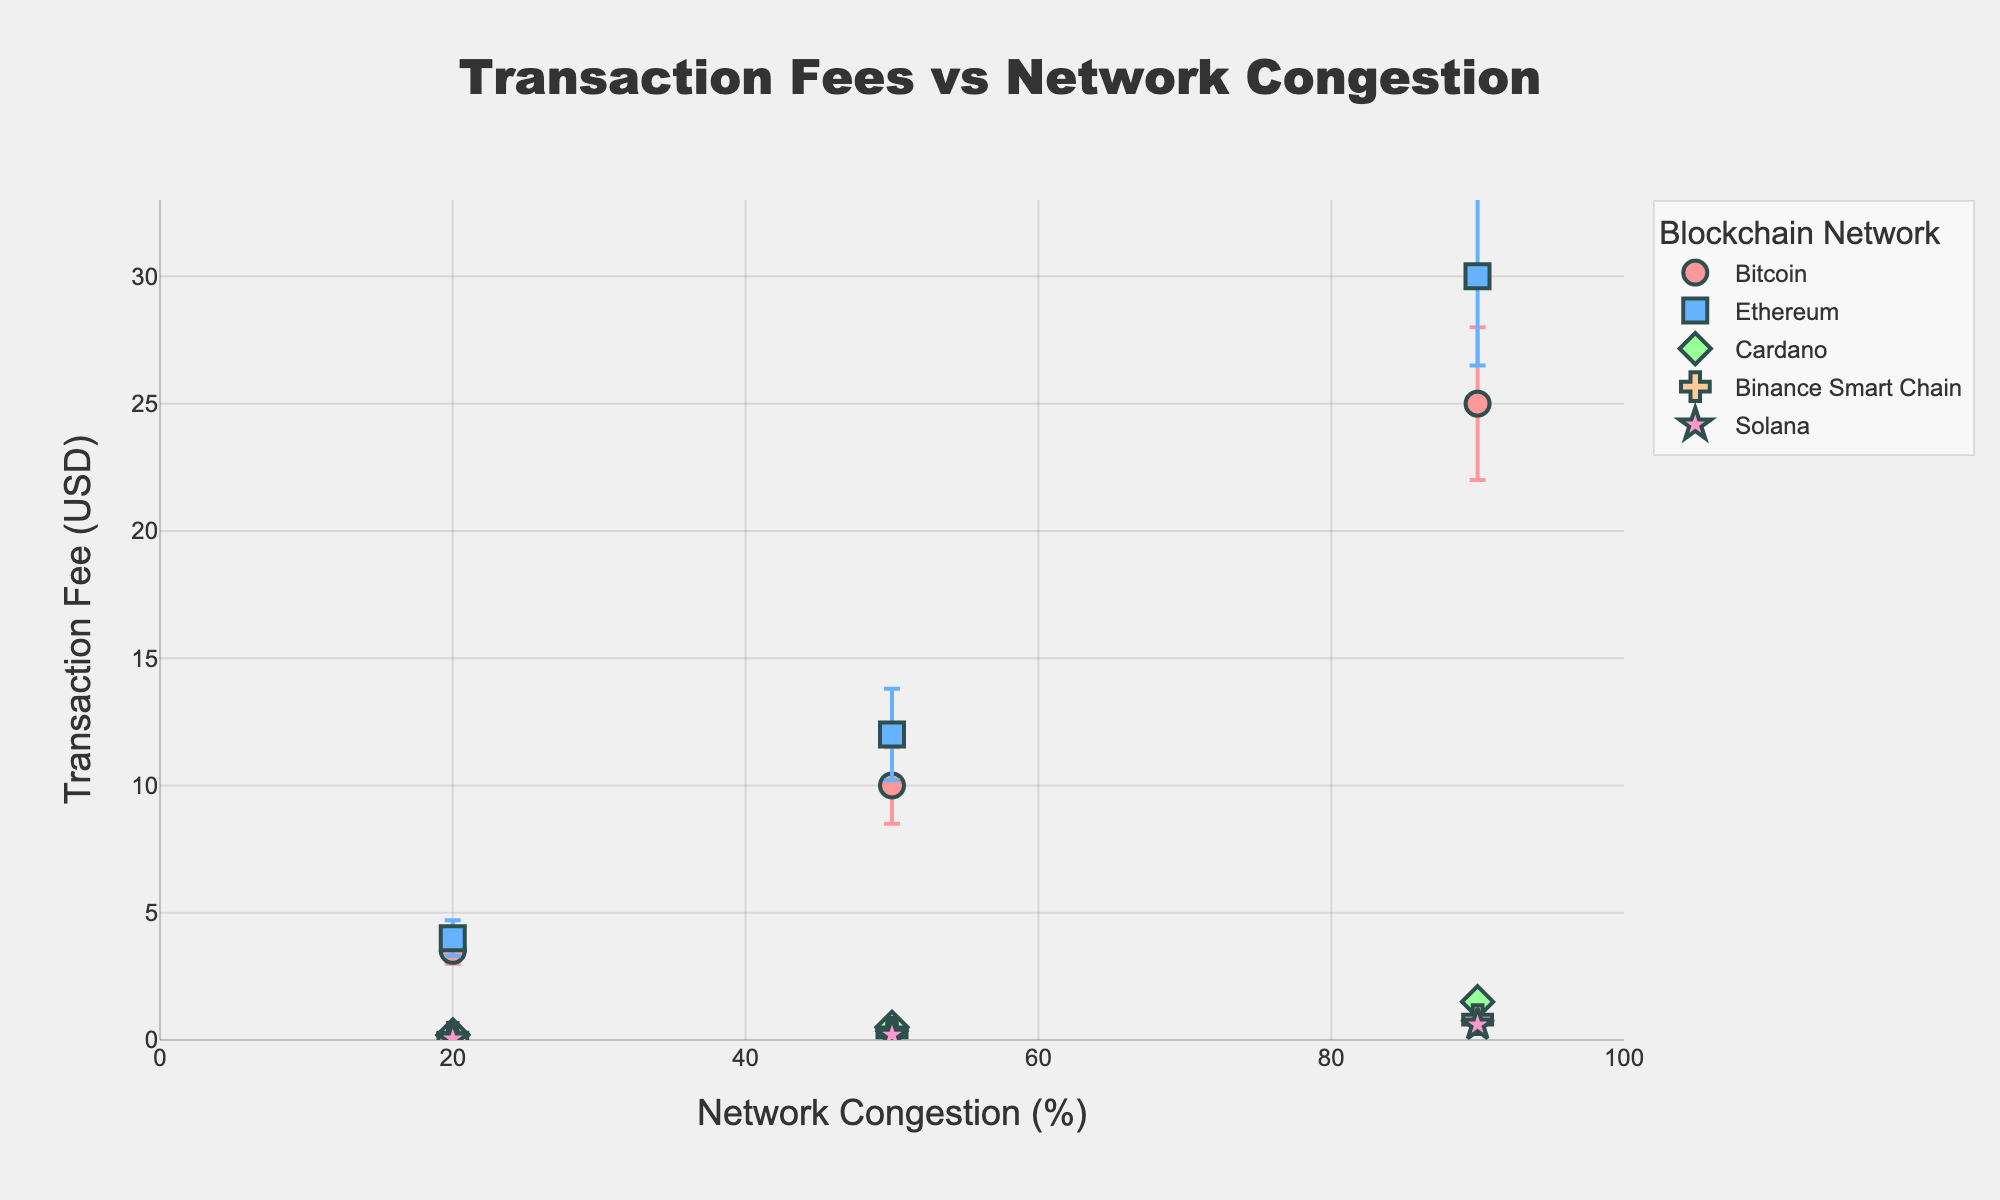Which blockchain network has the lowest transaction fee at 20% network congestion? To answer, look for the data points corresponding to 20% network congestion and identify the network with the lowest y-axis value (transaction fee).
Answer: Solana What is the general trend of transaction fees across different blockchain networks as network congestion increases from 20% to 90%? Observe the overall y-axis (transaction fee) values for each network as the x-axis (network congestion) values increase from 20% to 90%. Most networks show an increasing trend in transaction fees with rising network congestion.
Answer: Increasing trend Which network experiences the highest transaction fee at 90% network congestion? Look at the data points corresponding to 90% network congestion and identify the network with the highest y-axis value.
Answer: Ethereum What is the average transaction fee of Bitcoin across all levels of network congestion? Calculate the average of Bitcoin's transaction fees: (3.50 + 10.00 + 25.00) / 3.
Answer: 12.83 Between Ethereum and Bitcoin, which network has a higher transaction fee at 50% network congestion? Compare Ethereum's transaction fee (12.00) with Bitcoin's (10.00) at 50% network congestion.
Answer: Ethereum How does the error margin for transaction fees compare between Cardano and Binance Smart Chain at 90% network congestion? Compare the error margins at 90% network congestion; Cardano has an error margin of 0.20, while Binance Smart Chain has 0.10.
Answer: Cardano What is the range of transaction fees for Solana as network congestion goes from 20% to 90%? Identify the lowest (0.05 at 20%) and highest (0.60 at 90%) fees and calculate the range as the difference between them.
Answer: 0.55 Which blockchain network has the smallest variability in transaction fees across different levels of congestion? Analyze the range of transaction fees for each network and identify the one with the smallest difference between the highest and lowest fee. Solana ranges from 0.05 to 0.60.
Answer: Solana 